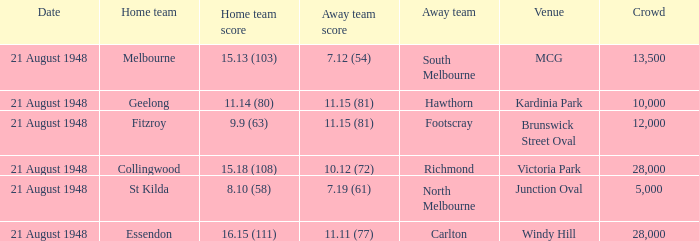When the Away team is south melbourne, what's the Home team score? 15.13 (103). 